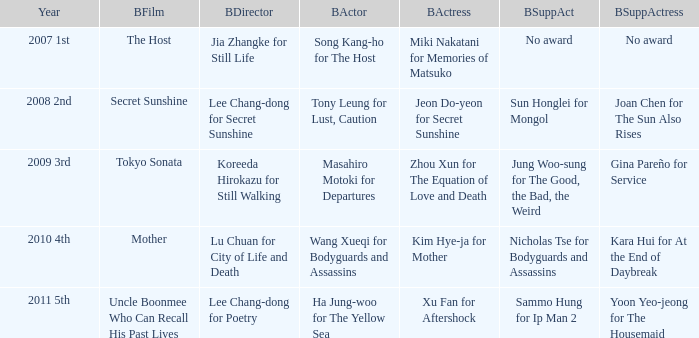Identify the top director for the movie "mother." Lu Chuan for City of Life and Death. 